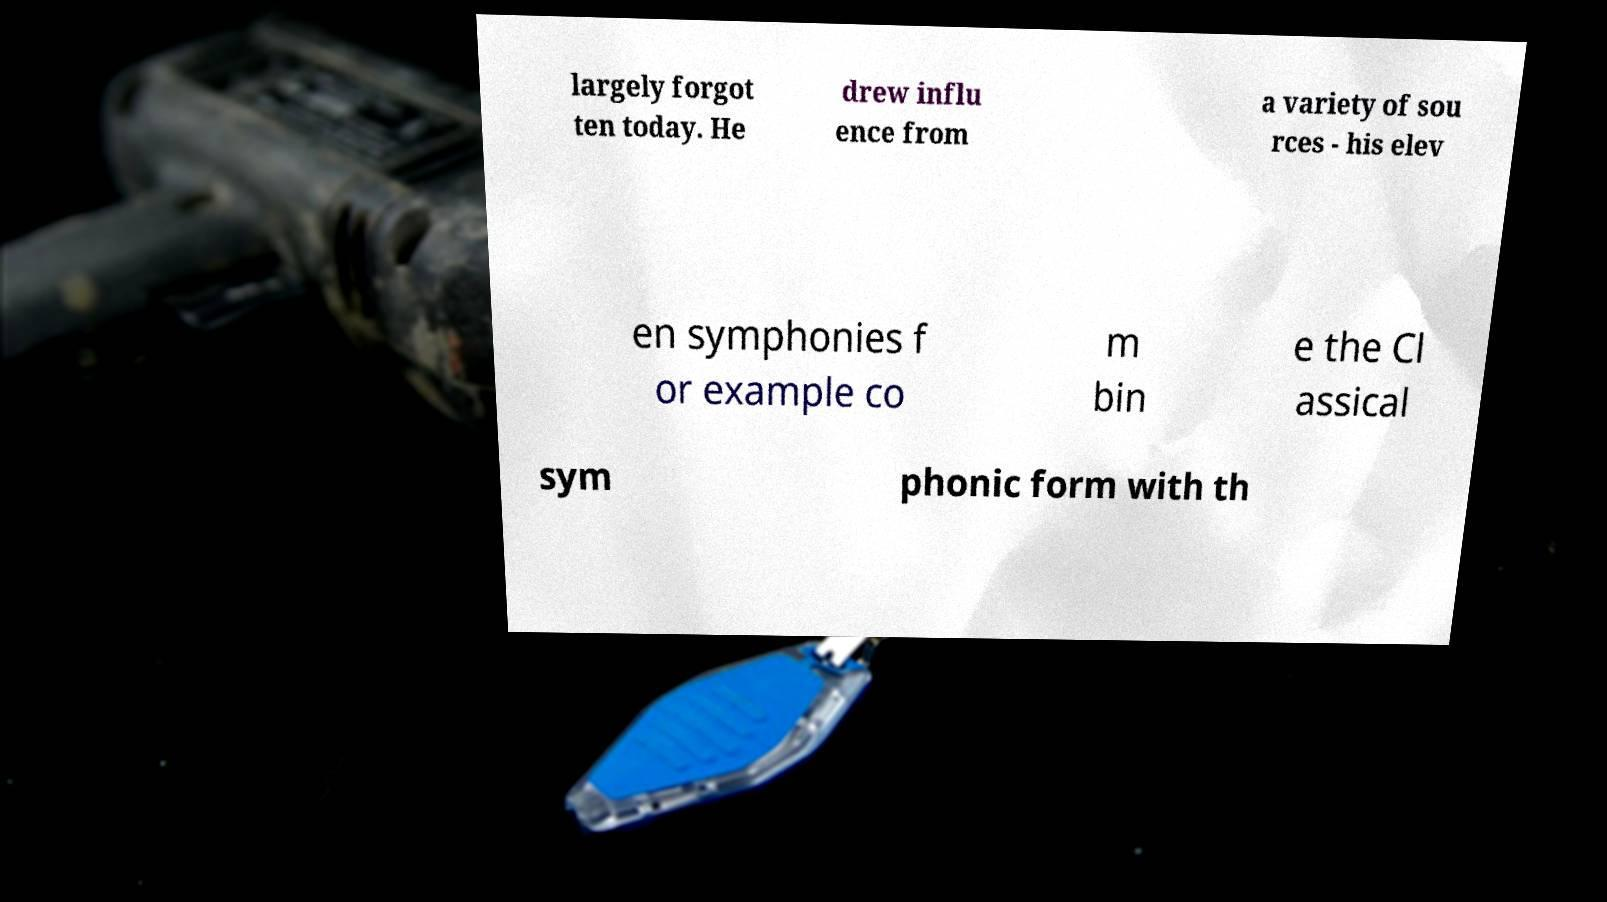There's text embedded in this image that I need extracted. Can you transcribe it verbatim? largely forgot ten today. He drew influ ence from a variety of sou rces - his elev en symphonies f or example co m bin e the Cl assical sym phonic form with th 